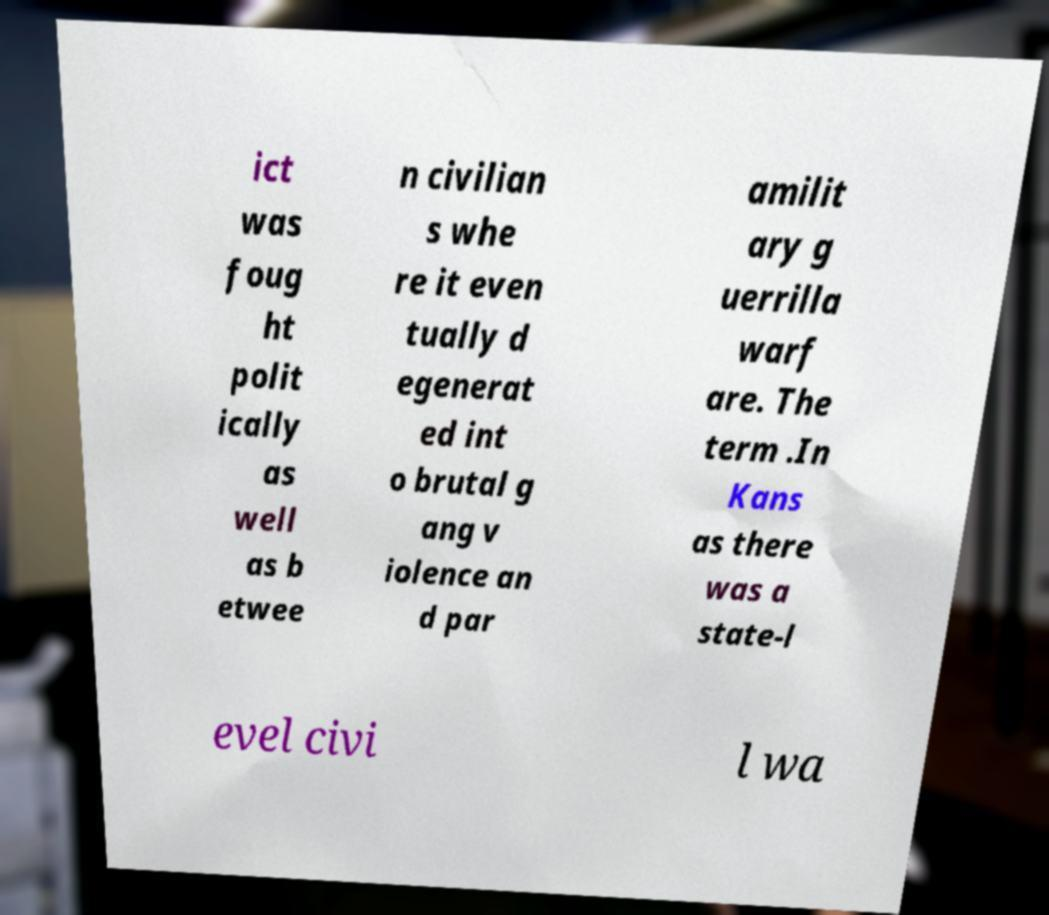What messages or text are displayed in this image? I need them in a readable, typed format. ict was foug ht polit ically as well as b etwee n civilian s whe re it even tually d egenerat ed int o brutal g ang v iolence an d par amilit ary g uerrilla warf are. The term .In Kans as there was a state-l evel civi l wa 